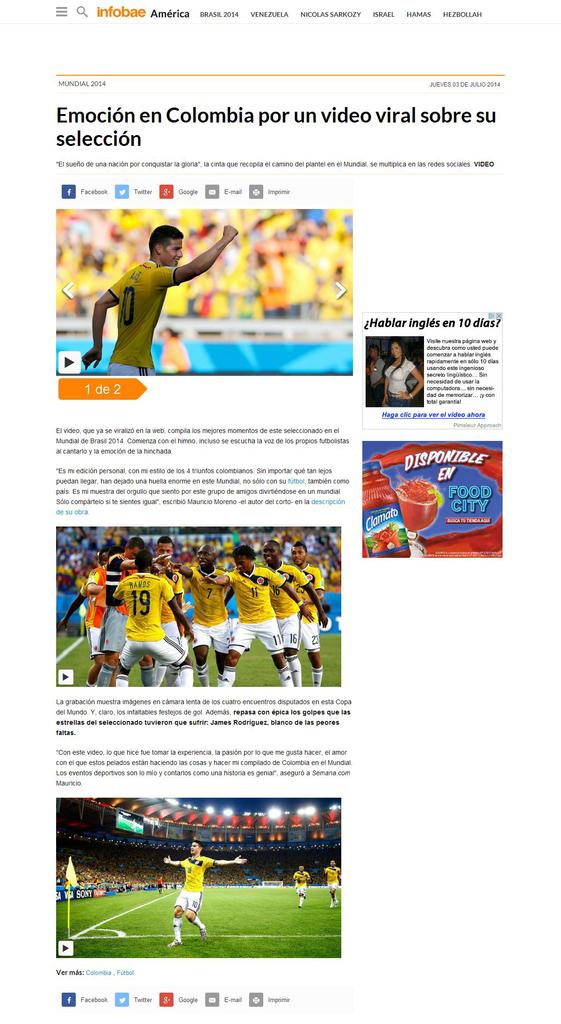What country is in the headline of this article?
Keep it short and to the point. Colombia. 